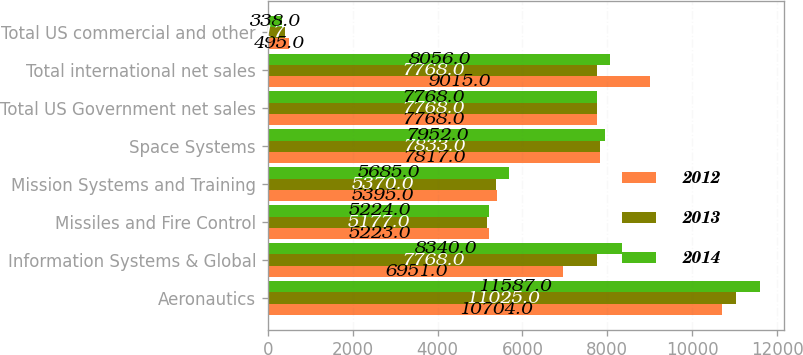<chart> <loc_0><loc_0><loc_500><loc_500><stacked_bar_chart><ecel><fcel>Aeronautics<fcel>Information Systems & Global<fcel>Missiles and Fire Control<fcel>Mission Systems and Training<fcel>Space Systems<fcel>Total US Government net sales<fcel>Total international net sales<fcel>Total US commercial and other<nl><fcel>2012<fcel>10704<fcel>6951<fcel>5223<fcel>5395<fcel>7817<fcel>7768<fcel>9015<fcel>495<nl><fcel>2013<fcel>11025<fcel>7768<fcel>5177<fcel>5370<fcel>7833<fcel>7768<fcel>7768<fcel>417<nl><fcel>2014<fcel>11587<fcel>8340<fcel>5224<fcel>5685<fcel>7952<fcel>7768<fcel>8056<fcel>338<nl></chart> 